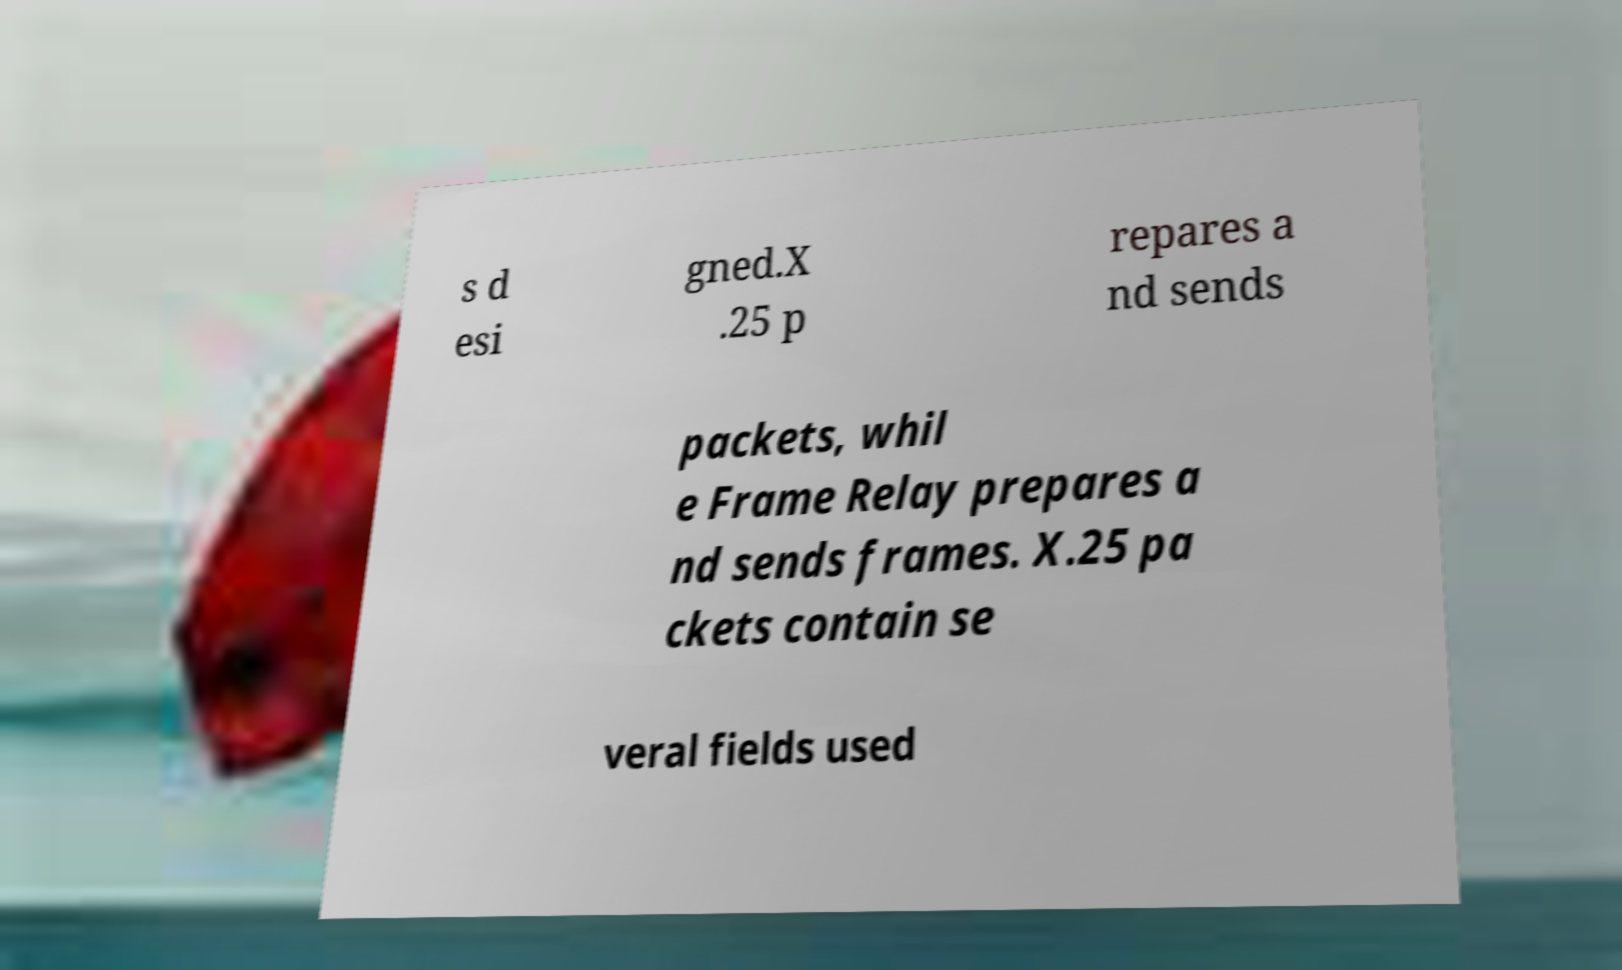For documentation purposes, I need the text within this image transcribed. Could you provide that? s d esi gned.X .25 p repares a nd sends packets, whil e Frame Relay prepares a nd sends frames. X.25 pa ckets contain se veral fields used 